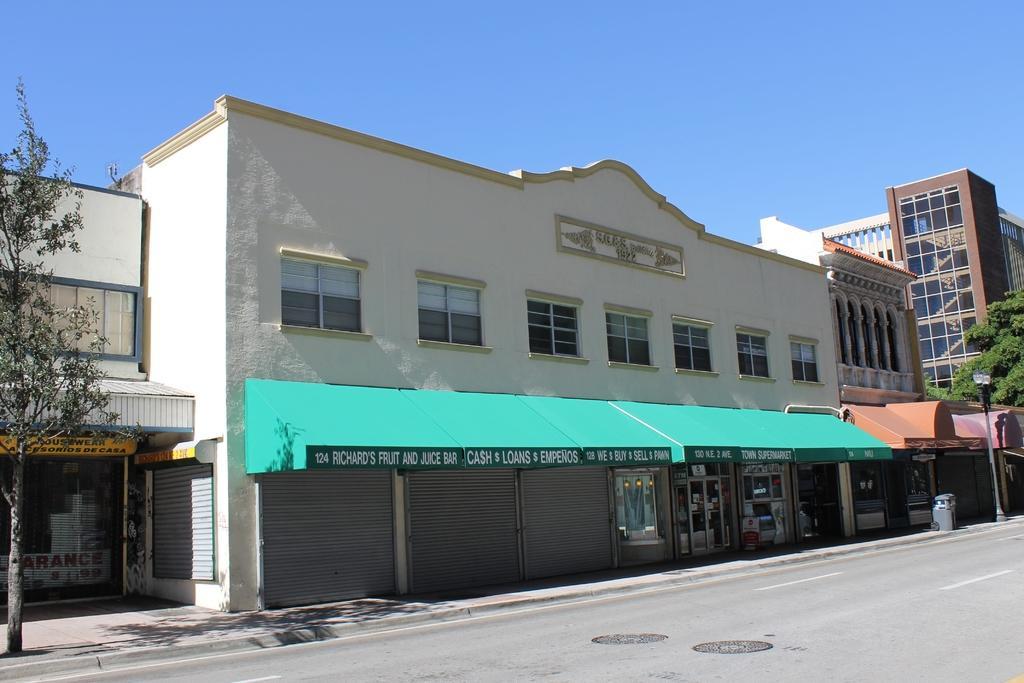How would you summarize this image in a sentence or two? This picture shows few buildings and trees and a pole light on the sidewalk and we see a dustbin and blue sky. 